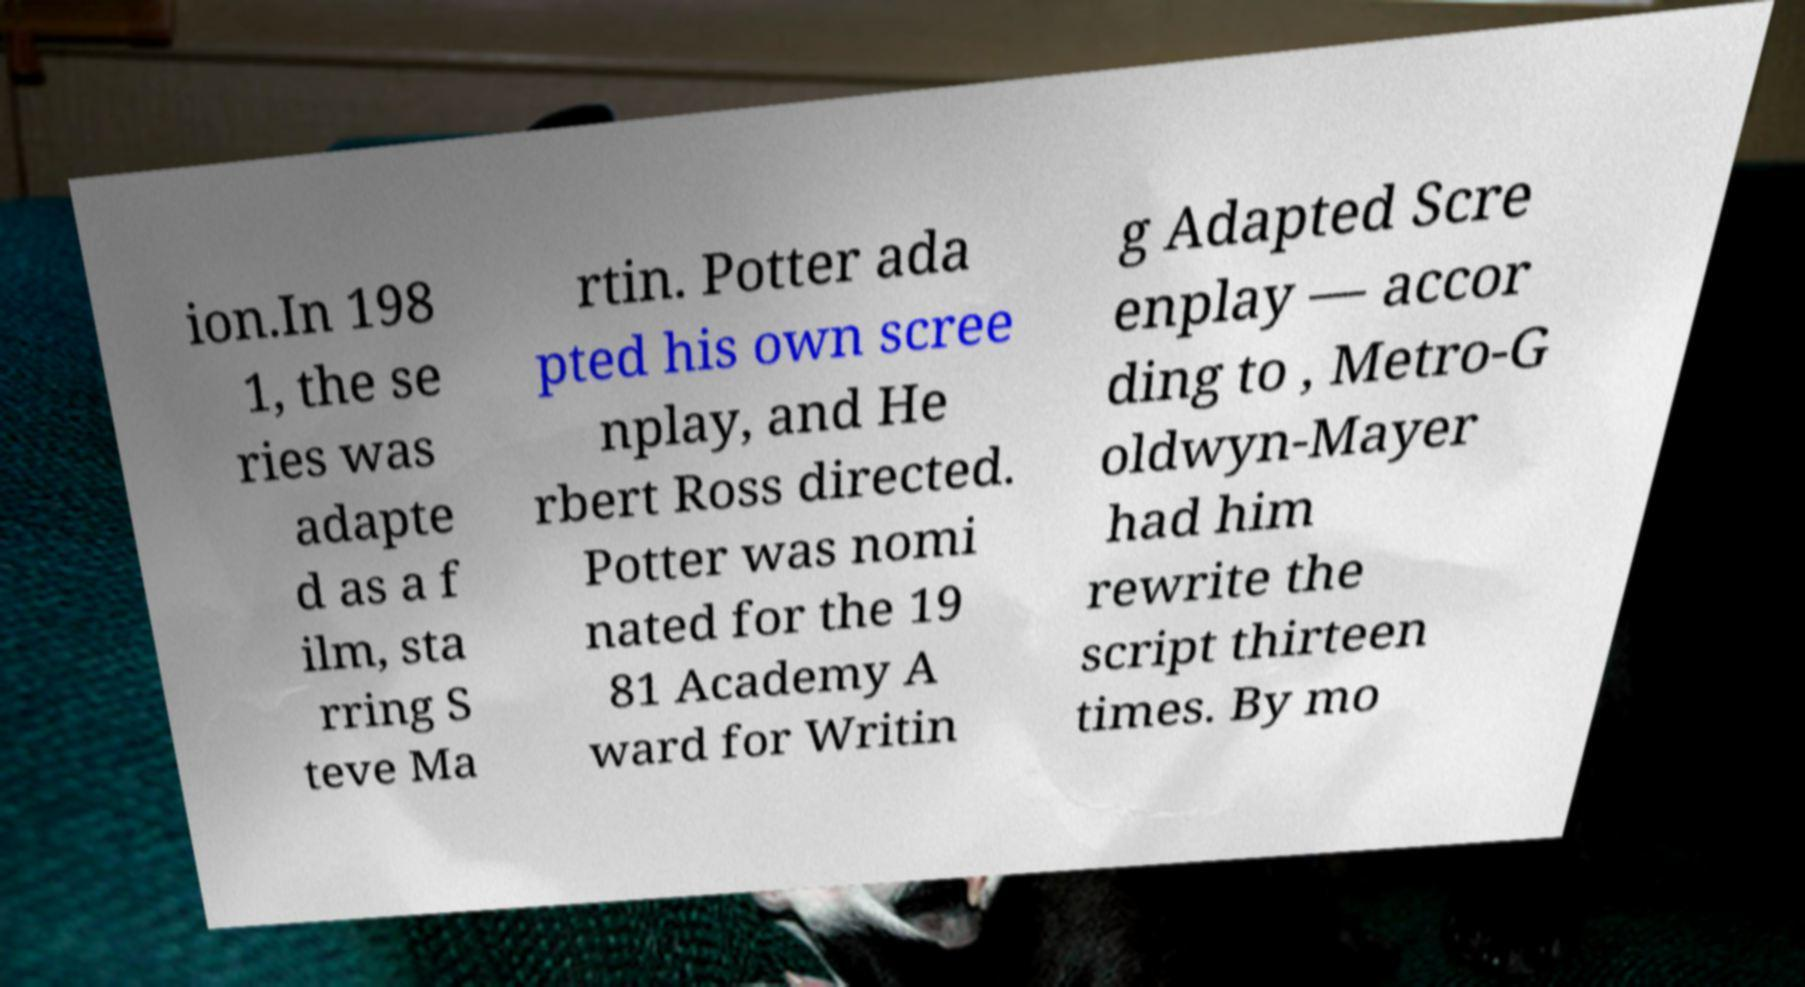Please read and relay the text visible in this image. What does it say? ion.In 198 1, the se ries was adapte d as a f ilm, sta rring S teve Ma rtin. Potter ada pted his own scree nplay, and He rbert Ross directed. Potter was nomi nated for the 19 81 Academy A ward for Writin g Adapted Scre enplay — accor ding to , Metro-G oldwyn-Mayer had him rewrite the script thirteen times. By mo 